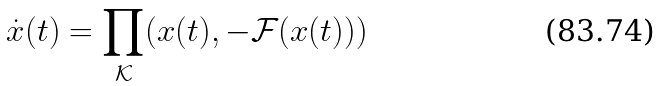Convert formula to latex. <formula><loc_0><loc_0><loc_500><loc_500>\dot { x } ( t ) = \prod _ { \mathcal { K } } ( x ( t ) , - \mathcal { F } ( x ( t ) ) )</formula> 